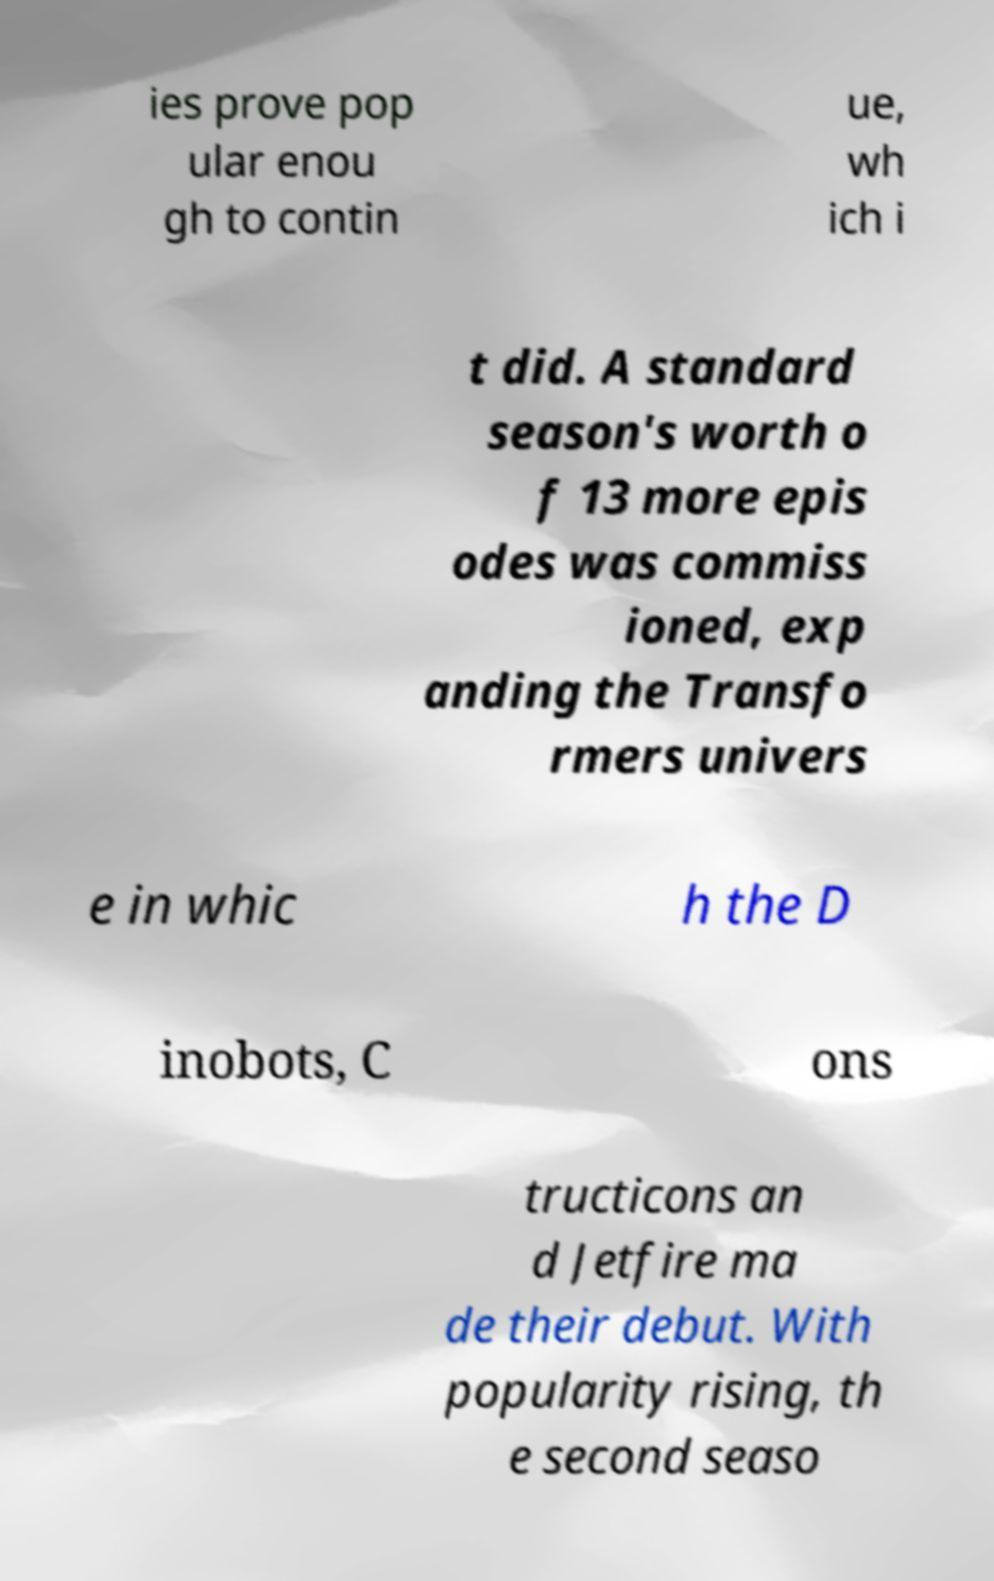Please read and relay the text visible in this image. What does it say? ies prove pop ular enou gh to contin ue, wh ich i t did. A standard season's worth o f 13 more epis odes was commiss ioned, exp anding the Transfo rmers univers e in whic h the D inobots, C ons tructicons an d Jetfire ma de their debut. With popularity rising, th e second seaso 